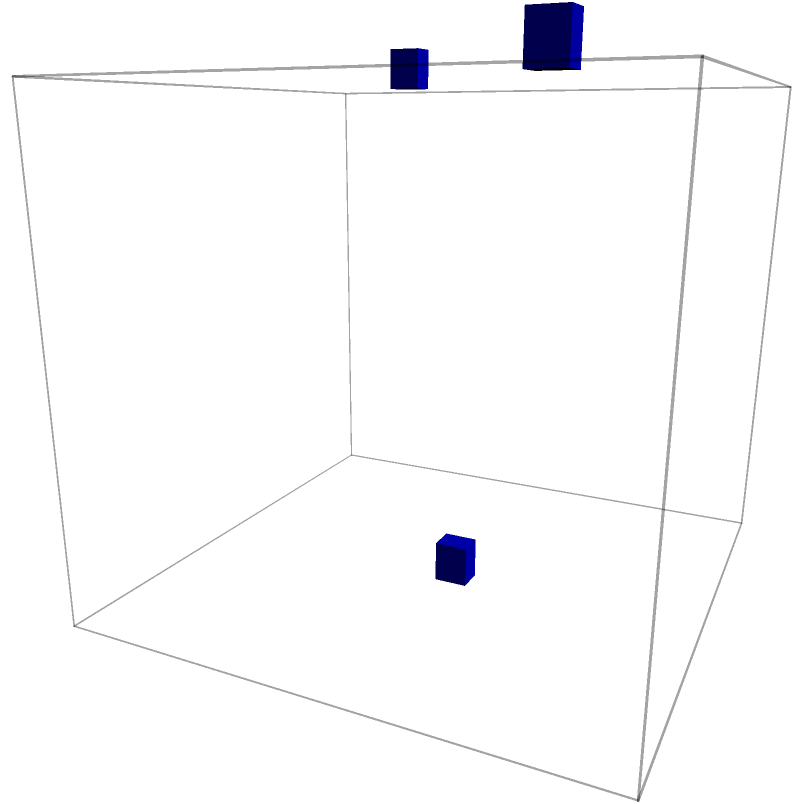In the 3D building layout shown, three HVAC units (A, B, and C) are connected by ducts. Which unit placement allows for the most efficient air distribution throughout the building, considering the total duct length and coverage area? To determine the most efficient HVAC unit placement, we need to consider the following factors:

1. Total duct length: Shorter ducts reduce energy loss and installation costs.
2. Coverage area: Units should be placed to maximize air distribution throughout the building.
3. Vertical and horizontal distribution: Efficient systems typically have a balance of both.

Let's analyze each unit:

A (top-left): 
- Connected to C via a long duct
- Covers the upper left corner of the building
- Provides both vertical and horizontal distribution

B (top-right):
- Connected to the central duct junction
- Covers the upper right corner of the building
- Provides mainly vertical distribution

C (bottom-center):
- Acts as a central distribution point
- Connected to both A and B
- Provides coverage for the lower levels of the building

The current layout shows an efficient design because:
1. Unit C acts as a central distribution point, minimizing total duct length.
2. Units A and B are placed at opposite corners, ensuring coverage of the entire upper level.
3. The vertical distribution from B and A to C allows for efficient air circulation between floors.

This configuration balances duct length, coverage area, and three-dimensional distribution, making it the most efficient placement for the given layout.
Answer: The current placement (A, B, and C) is most efficient. 